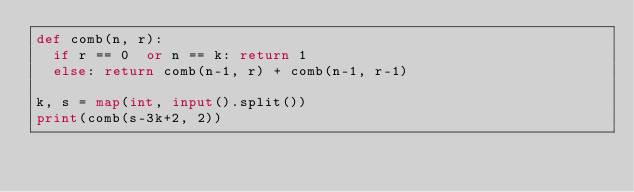<code> <loc_0><loc_0><loc_500><loc_500><_Python_>def comb(n, r):
  if r == 0  or n == k: return 1
  else: return comb(n-1, r) + comb(n-1, r-1)
 
k, s = map(int, input().split())
print(comb(s-3k+2, 2))</code> 